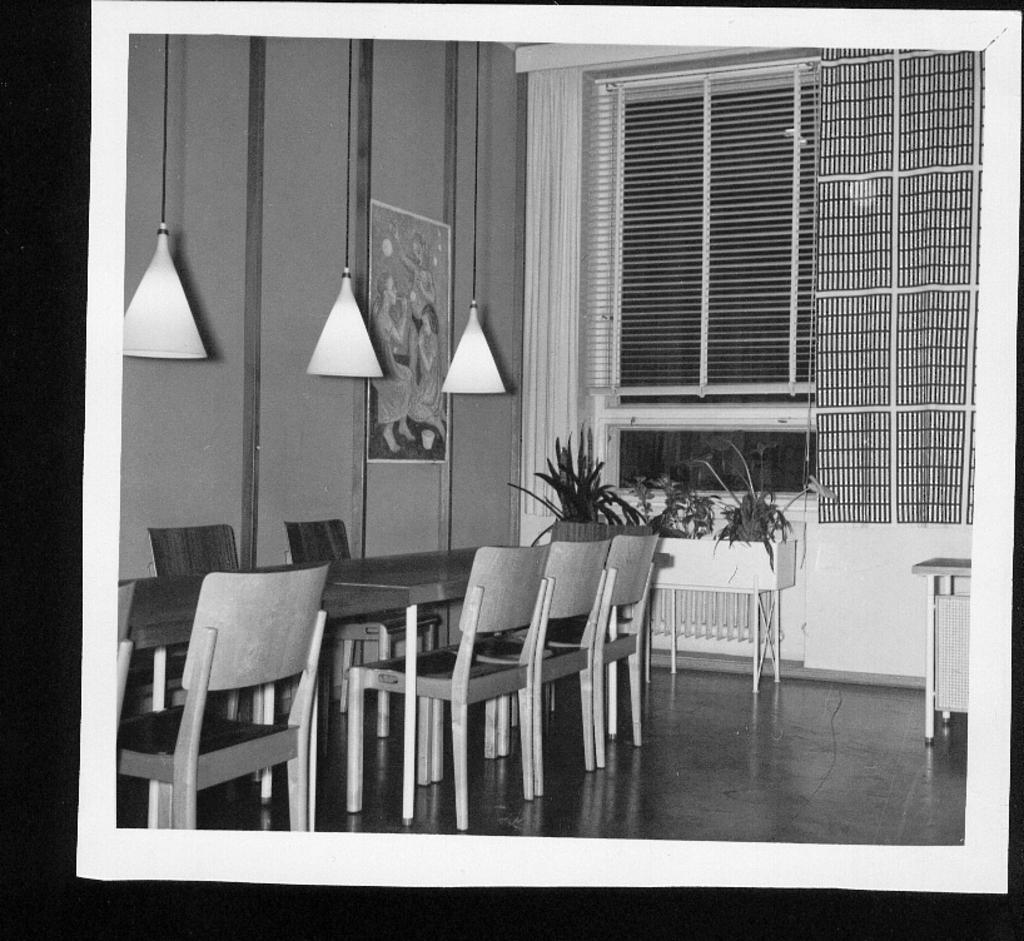Can you describe this image briefly? This is a black and white image where we can see chairs, tables flower pots, ceiling lights, poster on the wall, curtains, blinds to the glass windows in the background. 